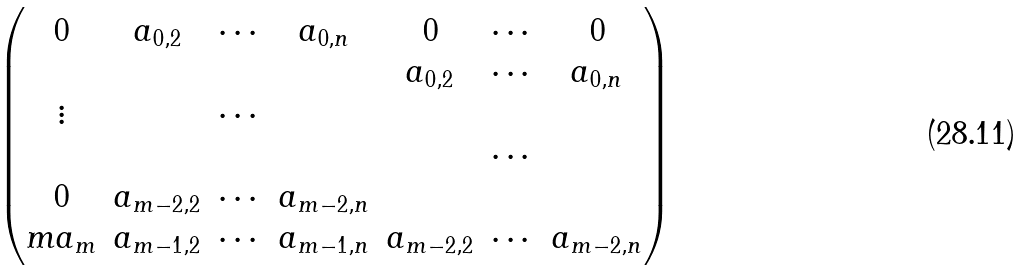<formula> <loc_0><loc_0><loc_500><loc_500>\begin{pmatrix} 0 & a _ { 0 , 2 } & \cdots & a _ { 0 , n } & 0 & \cdots & 0 \\ & & & & a _ { 0 , 2 } & \cdots & a _ { 0 , n } \\ \vdots & & \cdots & & & & \\ & & & & & \cdots & \\ 0 & a _ { m - 2 , 2 } & \cdots & a _ { m - 2 , n } & & & \\ m a _ { m } & a _ { m - 1 , 2 } & \cdots & a _ { m - 1 , n } & a _ { m - 2 , 2 } & \cdots & a _ { m - 2 , n } \end{pmatrix}</formula> 